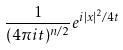<formula> <loc_0><loc_0><loc_500><loc_500>\frac { 1 } { ( 4 \pi i t ) ^ { n / 2 } } e ^ { i | x | ^ { 2 } / 4 t }</formula> 